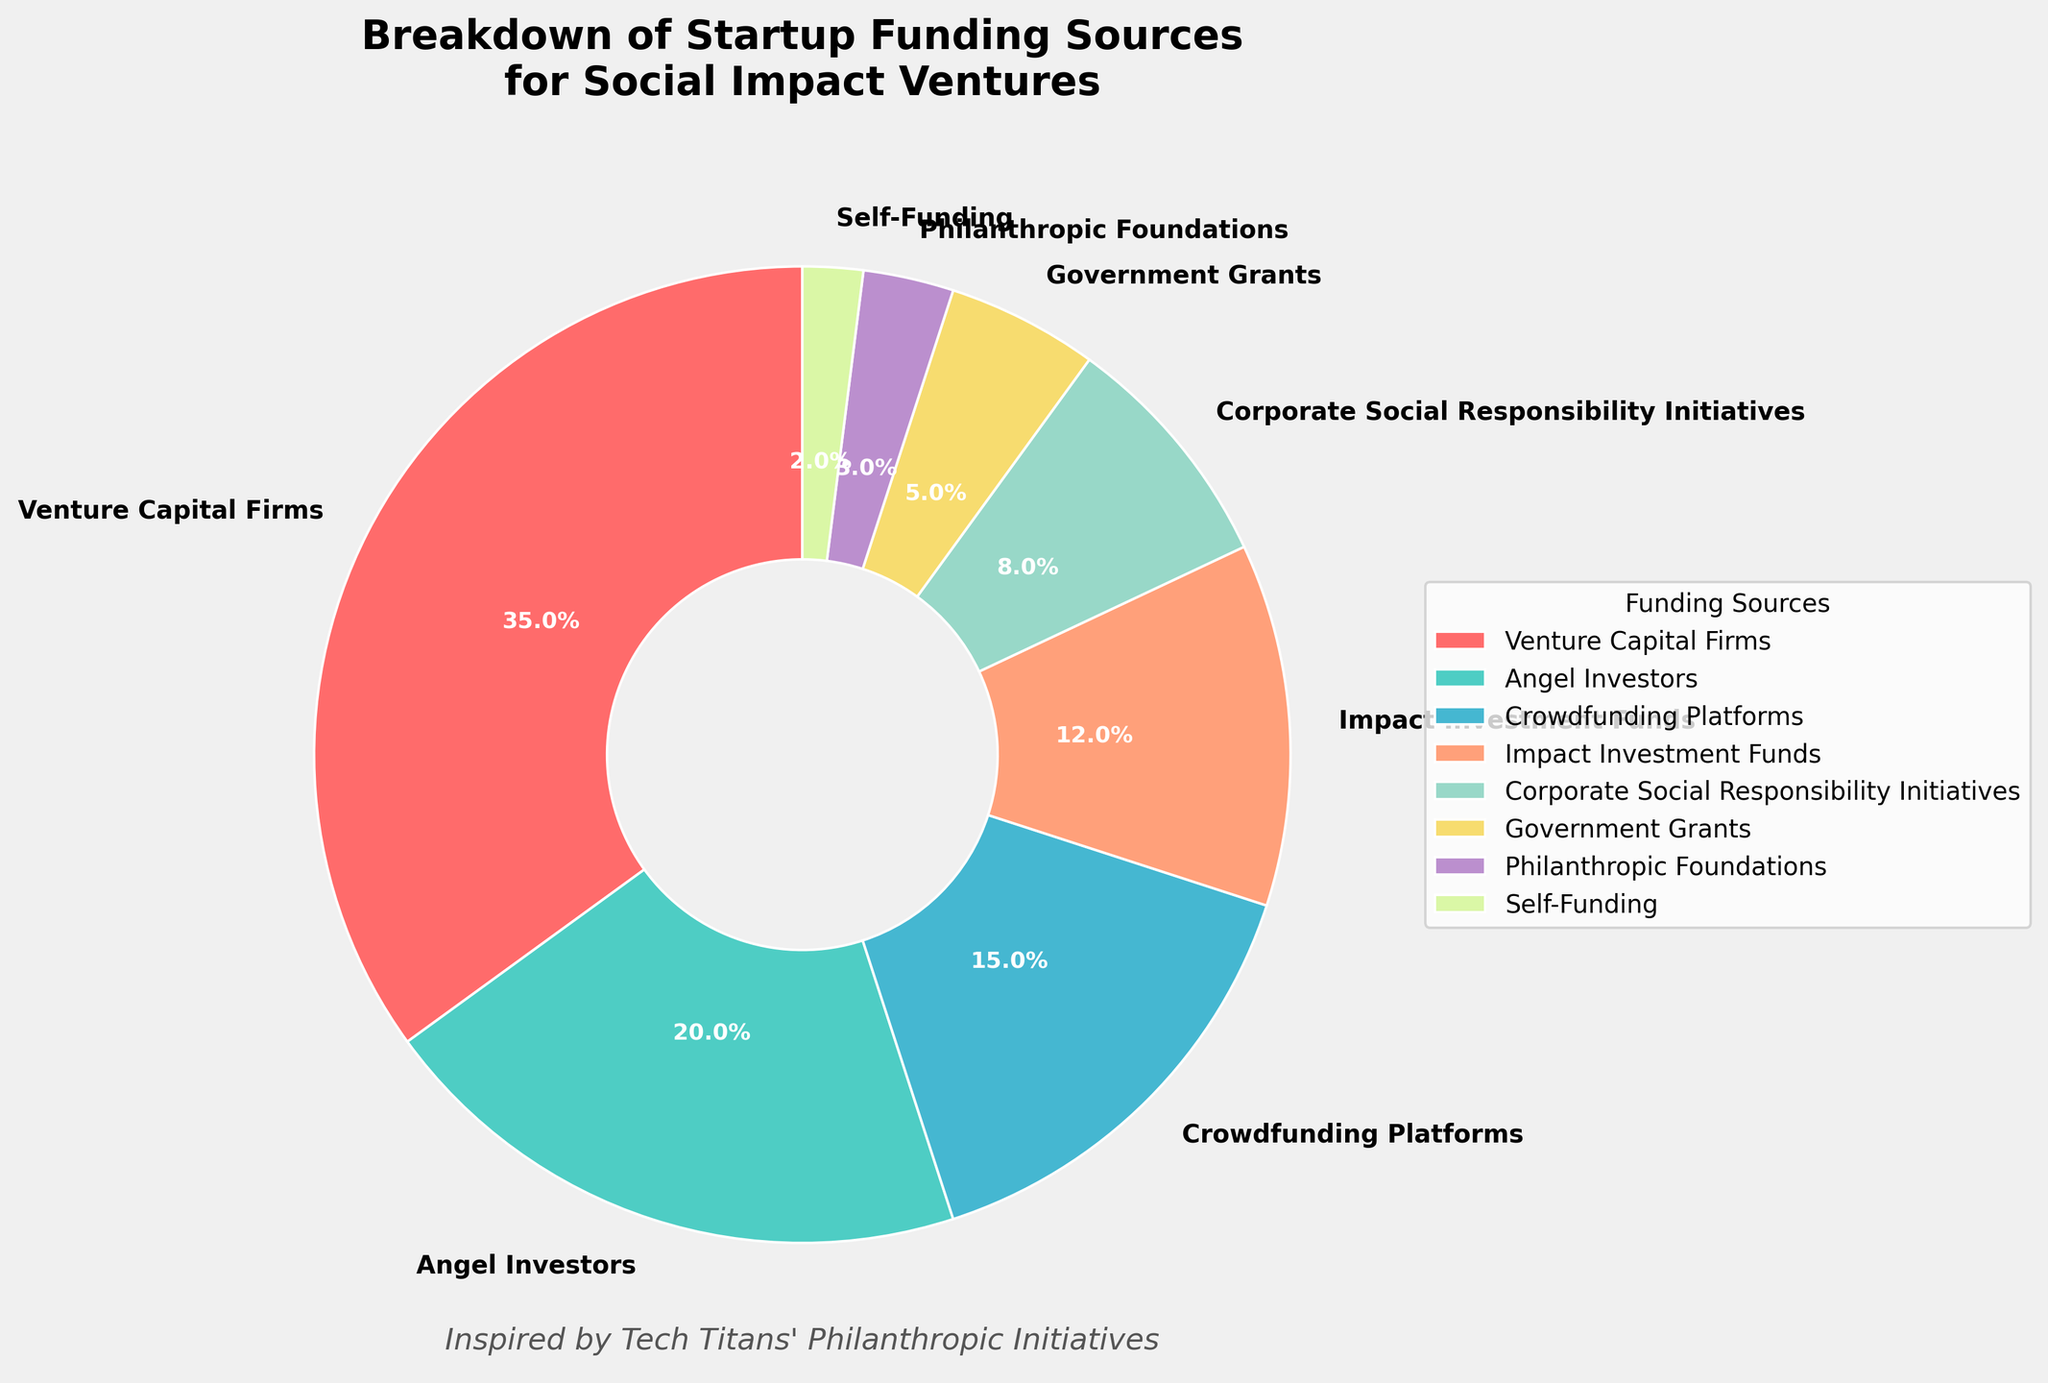What is the largest source of startup funding for social impact ventures? The pie chart shows different funding sources with varying percentages. The segment labeled "Venture Capital Firms" has the highest percentage (35%).
Answer: Venture Capital Firms How much larger is the percentage of funding from angel investors compared to self-funding? The percentage for angel investors is 20%, and for self-funding, it is 2%. The difference is calculated as 20% - 2%.
Answer: 18% What is the combined percentage of funding from corporate social responsibility initiatives and government grants? Corporate social responsibility initiatives contribute 8%, and government grants contribute 5%. The combined percentage is calculated as 8% + 5%.
Answer: 13% Which funding source has the smallest contribution? By looking at the pie chart, the smallest segment is labeled "Self-Funding" with 2%.
Answer: Self-Funding Between philanthropic foundations and crowdfunding platforms, which has a higher contribution and by how much? Philanthropic foundations contribute 3%, while crowdfunding platforms contribute 15%. The difference is calculated as 15% - 3%.
Answer: Crowdfunding platforms by 12% What is the total percentage of funding contributed by impact investment funds and government grants? Impact investment funds contribute 12%, and government grants contribute 5%. The total percentage is calculated as 12% + 5%.
Answer: 17% If corporate social responsibility initiatives and government grants were combined into one category, what would be its new percentage, and how would it rank compared to the other sources like angel investors? The combined percentage of corporate social responsibility initiatives (8%) and government grants (5%) would be 8% + 5% = 13%. Compared to angel investors (20%), the new category would rank below angel investors.
Answer: 13%, below angel investors Which color represents the category with the second highest funding source, and what is the respective percentage? The second highest funding source is angel investors, which is labeled with the color green in the pie chart and has a percentage of 20%.
Answer: Green, 20% In total, what percentage of funding do the top three sources contribute together? The top three sources are Venture Capital Firms (35%), Angel Investors (20%), and Crowdfunding Platforms (15%). The total percentage is calculated as 35% + 20% + 15%.
Answer: 70% What percentage more do venture capital firms contribute compared to impact investment funds? Venture capital firms contribute 35%, and impact investment funds contribute 12%. The percentage difference is calculated as 35% - 12%.
Answer: 23% 